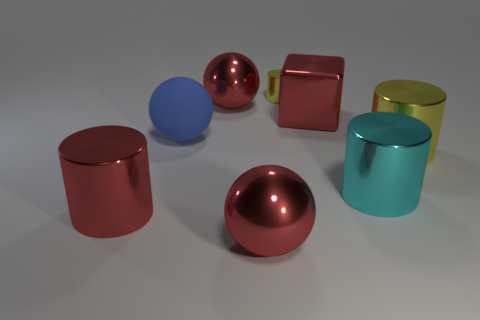Are any small cyan spheres visible?
Offer a terse response. No. There is a metal cylinder that is left of the large blue rubber thing; what color is it?
Provide a succinct answer. Red. There is a ball to the left of the large ball behind the rubber thing; how many yellow shiny things are to the left of it?
Provide a short and direct response. 0. What is the material of the ball that is behind the cyan object and in front of the metal block?
Provide a short and direct response. Rubber. Do the big cyan object and the yellow object behind the big yellow object have the same material?
Offer a very short reply. Yes. Are there more large yellow cylinders behind the big cyan metallic cylinder than cyan cylinders that are behind the large matte sphere?
Keep it short and to the point. Yes. What is the shape of the large rubber object?
Keep it short and to the point. Sphere. Are the cylinder behind the matte ball and the blue object that is behind the large yellow metal thing made of the same material?
Your answer should be very brief. No. What is the shape of the big red metal thing that is on the right side of the small metallic thing?
Make the answer very short. Cube. There is a red metallic thing that is the same shape as the tiny yellow shiny thing; what is its size?
Give a very brief answer. Large. 